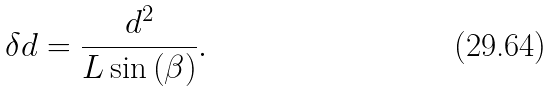<formula> <loc_0><loc_0><loc_500><loc_500>\delta d = \frac { d ^ { 2 } } { L \sin \left ( \beta \right ) } .</formula> 